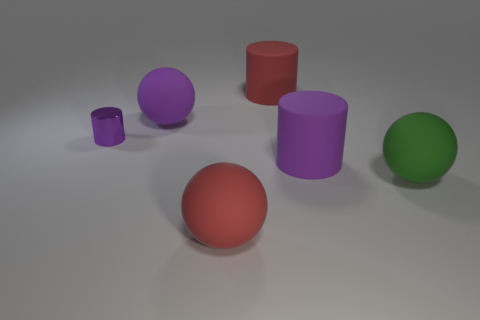Add 2 small things. How many objects exist? 8 Add 5 yellow metallic objects. How many yellow metallic objects exist? 5 Subtract 0 gray cubes. How many objects are left? 6 Subtract all big red objects. Subtract all purple things. How many objects are left? 1 Add 4 large green things. How many large green things are left? 5 